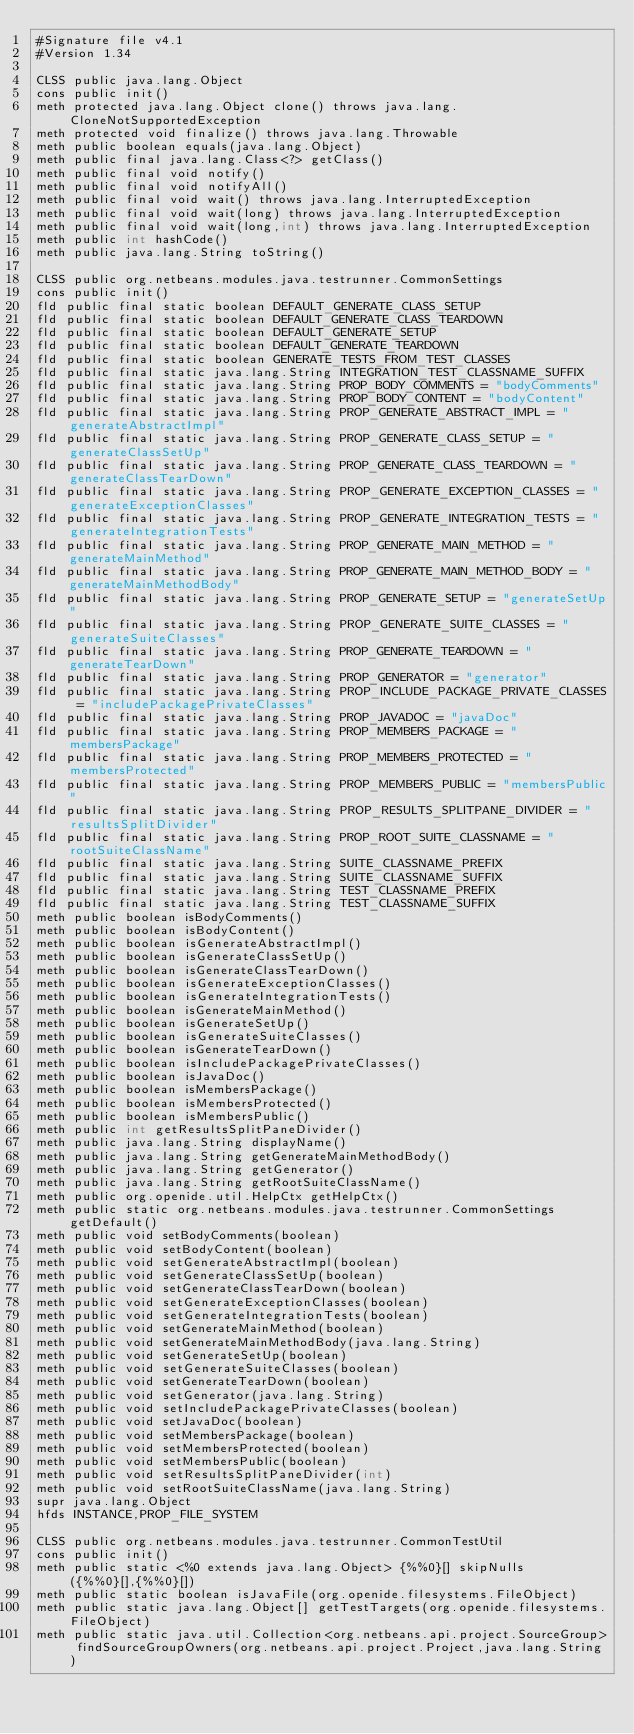<code> <loc_0><loc_0><loc_500><loc_500><_SML_>#Signature file v4.1
#Version 1.34

CLSS public java.lang.Object
cons public init()
meth protected java.lang.Object clone() throws java.lang.CloneNotSupportedException
meth protected void finalize() throws java.lang.Throwable
meth public boolean equals(java.lang.Object)
meth public final java.lang.Class<?> getClass()
meth public final void notify()
meth public final void notifyAll()
meth public final void wait() throws java.lang.InterruptedException
meth public final void wait(long) throws java.lang.InterruptedException
meth public final void wait(long,int) throws java.lang.InterruptedException
meth public int hashCode()
meth public java.lang.String toString()

CLSS public org.netbeans.modules.java.testrunner.CommonSettings
cons public init()
fld public final static boolean DEFAULT_GENERATE_CLASS_SETUP
fld public final static boolean DEFAULT_GENERATE_CLASS_TEARDOWN
fld public final static boolean DEFAULT_GENERATE_SETUP
fld public final static boolean DEFAULT_GENERATE_TEARDOWN
fld public final static boolean GENERATE_TESTS_FROM_TEST_CLASSES
fld public final static java.lang.String INTEGRATION_TEST_CLASSNAME_SUFFIX
fld public final static java.lang.String PROP_BODY_COMMENTS = "bodyComments"
fld public final static java.lang.String PROP_BODY_CONTENT = "bodyContent"
fld public final static java.lang.String PROP_GENERATE_ABSTRACT_IMPL = "generateAbstractImpl"
fld public final static java.lang.String PROP_GENERATE_CLASS_SETUP = "generateClassSetUp"
fld public final static java.lang.String PROP_GENERATE_CLASS_TEARDOWN = "generateClassTearDown"
fld public final static java.lang.String PROP_GENERATE_EXCEPTION_CLASSES = "generateExceptionClasses"
fld public final static java.lang.String PROP_GENERATE_INTEGRATION_TESTS = "generateIntegrationTests"
fld public final static java.lang.String PROP_GENERATE_MAIN_METHOD = "generateMainMethod"
fld public final static java.lang.String PROP_GENERATE_MAIN_METHOD_BODY = "generateMainMethodBody"
fld public final static java.lang.String PROP_GENERATE_SETUP = "generateSetUp"
fld public final static java.lang.String PROP_GENERATE_SUITE_CLASSES = "generateSuiteClasses"
fld public final static java.lang.String PROP_GENERATE_TEARDOWN = "generateTearDown"
fld public final static java.lang.String PROP_GENERATOR = "generator"
fld public final static java.lang.String PROP_INCLUDE_PACKAGE_PRIVATE_CLASSES = "includePackagePrivateClasses"
fld public final static java.lang.String PROP_JAVADOC = "javaDoc"
fld public final static java.lang.String PROP_MEMBERS_PACKAGE = "membersPackage"
fld public final static java.lang.String PROP_MEMBERS_PROTECTED = "membersProtected"
fld public final static java.lang.String PROP_MEMBERS_PUBLIC = "membersPublic"
fld public final static java.lang.String PROP_RESULTS_SPLITPANE_DIVIDER = "resultsSplitDivider"
fld public final static java.lang.String PROP_ROOT_SUITE_CLASSNAME = "rootSuiteClassName"
fld public final static java.lang.String SUITE_CLASSNAME_PREFIX
fld public final static java.lang.String SUITE_CLASSNAME_SUFFIX
fld public final static java.lang.String TEST_CLASSNAME_PREFIX
fld public final static java.lang.String TEST_CLASSNAME_SUFFIX
meth public boolean isBodyComments()
meth public boolean isBodyContent()
meth public boolean isGenerateAbstractImpl()
meth public boolean isGenerateClassSetUp()
meth public boolean isGenerateClassTearDown()
meth public boolean isGenerateExceptionClasses()
meth public boolean isGenerateIntegrationTests()
meth public boolean isGenerateMainMethod()
meth public boolean isGenerateSetUp()
meth public boolean isGenerateSuiteClasses()
meth public boolean isGenerateTearDown()
meth public boolean isIncludePackagePrivateClasses()
meth public boolean isJavaDoc()
meth public boolean isMembersPackage()
meth public boolean isMembersProtected()
meth public boolean isMembersPublic()
meth public int getResultsSplitPaneDivider()
meth public java.lang.String displayName()
meth public java.lang.String getGenerateMainMethodBody()
meth public java.lang.String getGenerator()
meth public java.lang.String getRootSuiteClassName()
meth public org.openide.util.HelpCtx getHelpCtx()
meth public static org.netbeans.modules.java.testrunner.CommonSettings getDefault()
meth public void setBodyComments(boolean)
meth public void setBodyContent(boolean)
meth public void setGenerateAbstractImpl(boolean)
meth public void setGenerateClassSetUp(boolean)
meth public void setGenerateClassTearDown(boolean)
meth public void setGenerateExceptionClasses(boolean)
meth public void setGenerateIntegrationTests(boolean)
meth public void setGenerateMainMethod(boolean)
meth public void setGenerateMainMethodBody(java.lang.String)
meth public void setGenerateSetUp(boolean)
meth public void setGenerateSuiteClasses(boolean)
meth public void setGenerateTearDown(boolean)
meth public void setGenerator(java.lang.String)
meth public void setIncludePackagePrivateClasses(boolean)
meth public void setJavaDoc(boolean)
meth public void setMembersPackage(boolean)
meth public void setMembersProtected(boolean)
meth public void setMembersPublic(boolean)
meth public void setResultsSplitPaneDivider(int)
meth public void setRootSuiteClassName(java.lang.String)
supr java.lang.Object
hfds INSTANCE,PROP_FILE_SYSTEM

CLSS public org.netbeans.modules.java.testrunner.CommonTestUtil
cons public init()
meth public static <%0 extends java.lang.Object> {%%0}[] skipNulls({%%0}[],{%%0}[])
meth public static boolean isJavaFile(org.openide.filesystems.FileObject)
meth public static java.lang.Object[] getTestTargets(org.openide.filesystems.FileObject)
meth public static java.util.Collection<org.netbeans.api.project.SourceGroup> findSourceGroupOwners(org.netbeans.api.project.Project,java.lang.String)</code> 